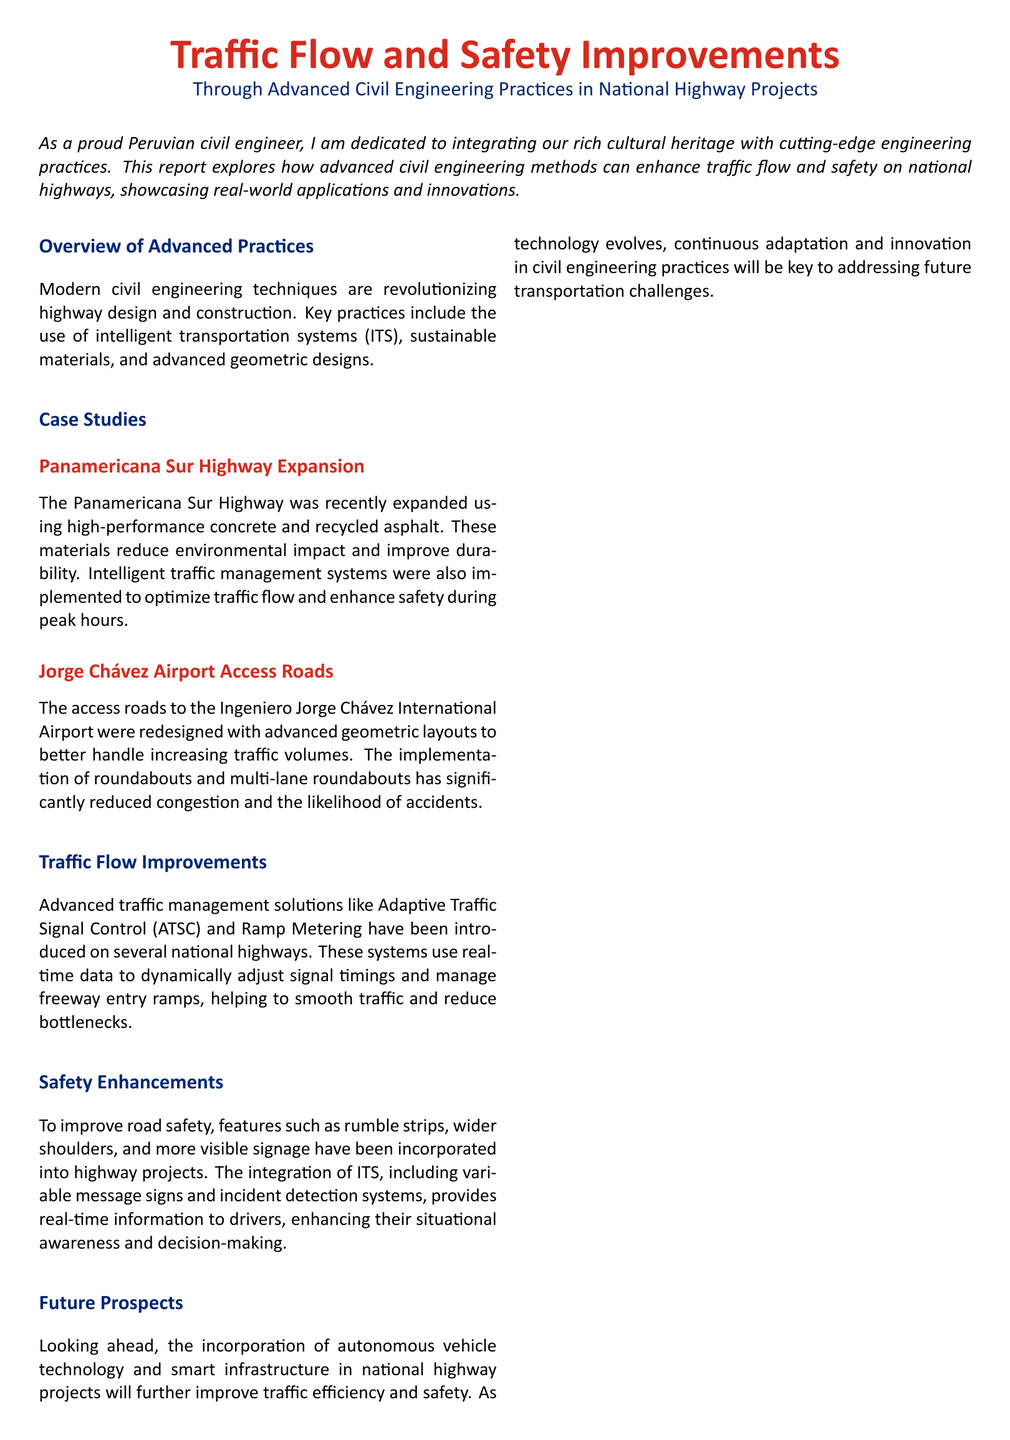What is the title of the report? The title of the report is stated at the beginning, highlighting the focus on traffic flow and safety improvements in national highway projects.
Answer: Traffic Flow and Safety Improvements Which highway was recently expanded? The report mentions the specific highway that underwent expansion and the advanced practices used in that project.
Answer: Panamericana Sur Highway What material was used to reduce environmental impact? The document specifies the material used in the expansion of the highway that also enhances durability.
Answer: Recycled asphalt What advanced system is mentioned for traffic management? The report lists a specific traffic management solution that utilizes real-time data to improve traffic conditions.
Answer: Adaptive Traffic Signal Control Which airport's access roads were redesigned? The document indicates the airport associated with the redesigned access roads and the improvements made.
Answer: Ingeniero Jorge Chávez International Airport What feature improves situational awareness for drivers? The report describes an integrated system that enhances the information available to drivers on the highways.
Answer: Variable message signs What geometric layout was implemented to reduce congestion? The document discusses a specific geometric design that has significantly alleviated traffic issues.
Answer: Roundabouts What does the report highlight about future prospects? The document hints at potential advancements that will be integrated into highway projects in the future.
Answer: Autonomous vehicle technology What is the primary goal of the implemented engineering practices? The report summarizes the main objective of the engineering practices discussed throughout the document.
Answer: Efficiency and safety 